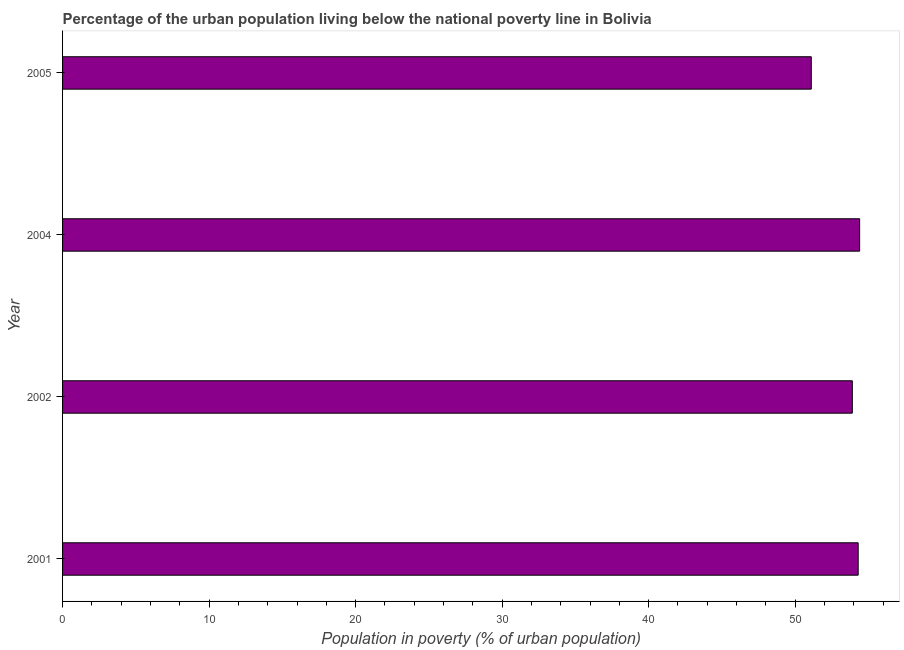What is the title of the graph?
Offer a very short reply. Percentage of the urban population living below the national poverty line in Bolivia. What is the label or title of the X-axis?
Provide a short and direct response. Population in poverty (% of urban population). What is the percentage of urban population living below poverty line in 2001?
Make the answer very short. 54.3. Across all years, what is the maximum percentage of urban population living below poverty line?
Give a very brief answer. 54.4. Across all years, what is the minimum percentage of urban population living below poverty line?
Offer a terse response. 51.1. In which year was the percentage of urban population living below poverty line minimum?
Provide a short and direct response. 2005. What is the sum of the percentage of urban population living below poverty line?
Provide a succinct answer. 213.7. What is the average percentage of urban population living below poverty line per year?
Your answer should be very brief. 53.42. What is the median percentage of urban population living below poverty line?
Offer a very short reply. 54.1. In how many years, is the percentage of urban population living below poverty line greater than 2 %?
Your answer should be very brief. 4. Do a majority of the years between 2002 and 2004 (inclusive) have percentage of urban population living below poverty line greater than 18 %?
Offer a terse response. Yes. What is the ratio of the percentage of urban population living below poverty line in 2004 to that in 2005?
Your answer should be compact. 1.06. What is the difference between the highest and the second highest percentage of urban population living below poverty line?
Your response must be concise. 0.1. In how many years, is the percentage of urban population living below poverty line greater than the average percentage of urban population living below poverty line taken over all years?
Offer a very short reply. 3. How many bars are there?
Offer a very short reply. 4. How many years are there in the graph?
Offer a terse response. 4. What is the Population in poverty (% of urban population) in 2001?
Make the answer very short. 54.3. What is the Population in poverty (% of urban population) of 2002?
Provide a short and direct response. 53.9. What is the Population in poverty (% of urban population) of 2004?
Ensure brevity in your answer.  54.4. What is the Population in poverty (% of urban population) of 2005?
Make the answer very short. 51.1. What is the ratio of the Population in poverty (% of urban population) in 2001 to that in 2004?
Give a very brief answer. 1. What is the ratio of the Population in poverty (% of urban population) in 2001 to that in 2005?
Provide a short and direct response. 1.06. What is the ratio of the Population in poverty (% of urban population) in 2002 to that in 2004?
Give a very brief answer. 0.99. What is the ratio of the Population in poverty (% of urban population) in 2002 to that in 2005?
Your answer should be very brief. 1.05. What is the ratio of the Population in poverty (% of urban population) in 2004 to that in 2005?
Offer a terse response. 1.06. 